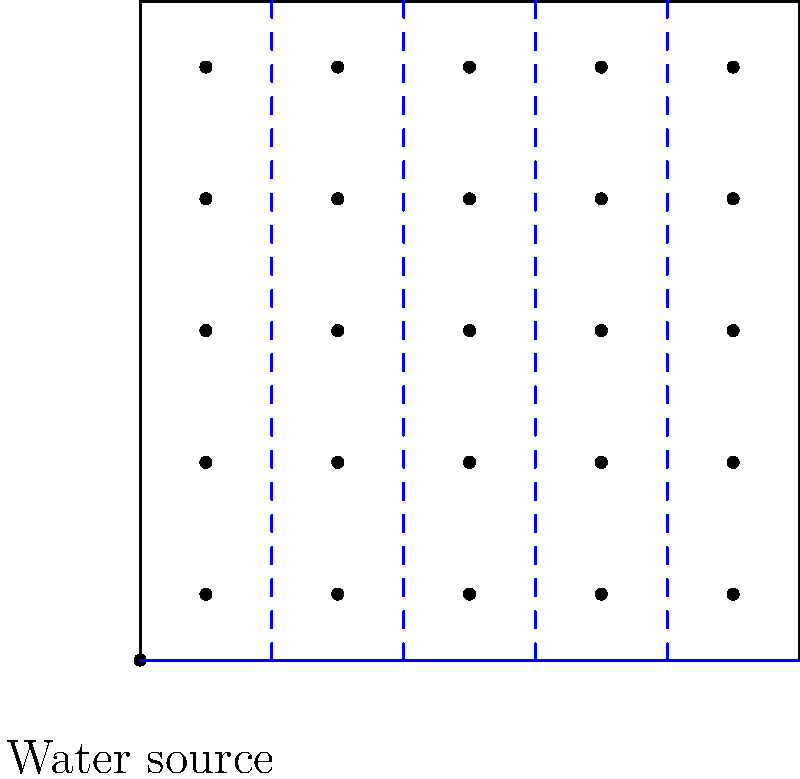Given a square farm plot of 100m x 100m with a water source at one corner and crops planted in a 5x5 grid, design an efficient irrigation system layout. Calculate the total length of piping needed if the main pipeline runs along one edge and secondary pipelines branch perpendicularly to reach each row of crops. What is the total length of piping required in meters? To solve this problem, we'll follow these steps:

1. Identify the main pipeline:
   - The main pipeline runs along one edge of the farm, which is 100m long.

2. Calculate the number and length of secondary pipelines:
   - There are 5 rows of crops, so we need 5 secondary pipelines.
   - Each secondary pipeline runs from the main pipeline to the opposite edge of the farm.
   - The length of each secondary pipeline is 100m.

3. Calculate the total length of piping:
   - Main pipeline length: 100m
   - Secondary pipelines: 5 × 100m = 500m
   - Total length = Main pipeline + Secondary pipelines
   - Total length = 100m + 500m = 600m

Therefore, the total length of piping required for this irrigation system layout is 600 meters.

This design is efficient because:
a) It minimizes the length of the main pipeline by running it along one edge.
b) It uses perpendicular secondary pipelines to reach all crop rows with minimal additional piping.
c) It allows for easy maintenance and potential future expansion.
Answer: 600 meters 